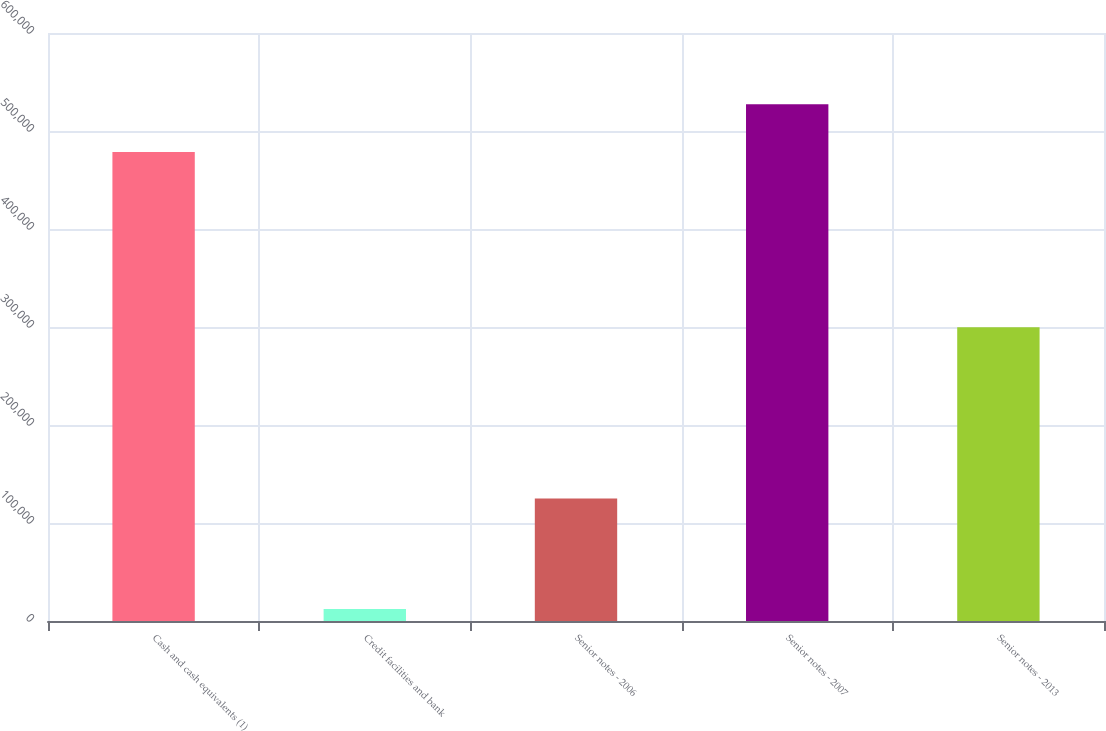<chart> <loc_0><loc_0><loc_500><loc_500><bar_chart><fcel>Cash and cash equivalents (1)<fcel>Credit facilities and bank<fcel>Senior notes - 2006<fcel>Senior notes - 2007<fcel>Senior notes - 2013<nl><fcel>478573<fcel>12335<fcel>125000<fcel>527340<fcel>299782<nl></chart> 